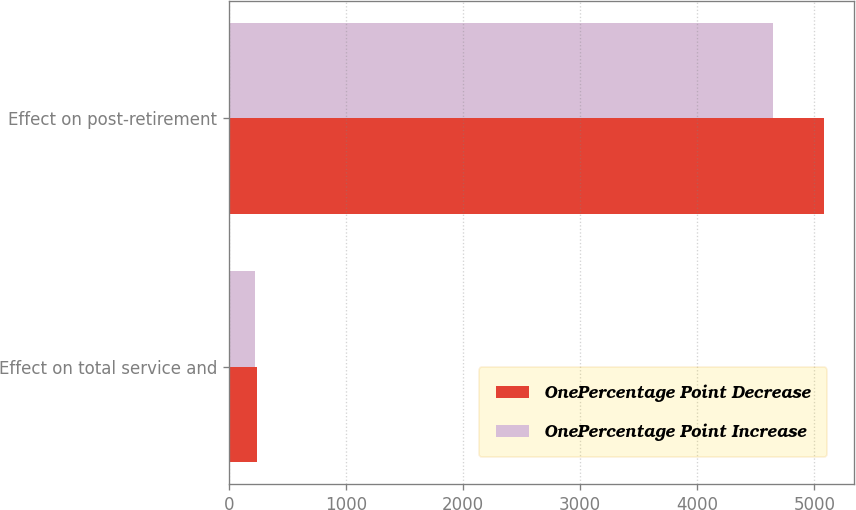Convert chart to OTSL. <chart><loc_0><loc_0><loc_500><loc_500><stacked_bar_chart><ecel><fcel>Effect on total service and<fcel>Effect on post-retirement<nl><fcel>OnePercentage Point Decrease<fcel>240<fcel>5082<nl><fcel>OnePercentage Point Increase<fcel>218<fcel>4650<nl></chart> 